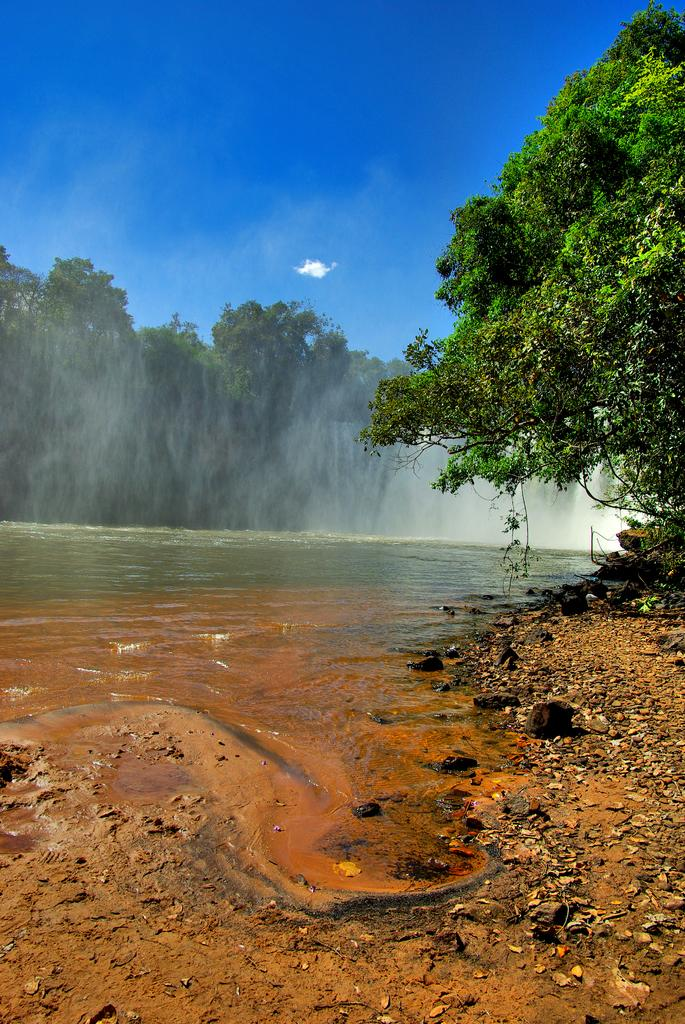What is visible in the image? Water is visible in the image. What can be seen in the background of the image? There are trees in the background of the image. What is the color of the trees? The trees are green. What is the color of the sky in the image? The sky is blue. Where is the zinc located in the image? There is no zinc present in the image. What type of bean is growing on the trees in the image? There are no beans present in the image, as the trees are green and not bean plants. 